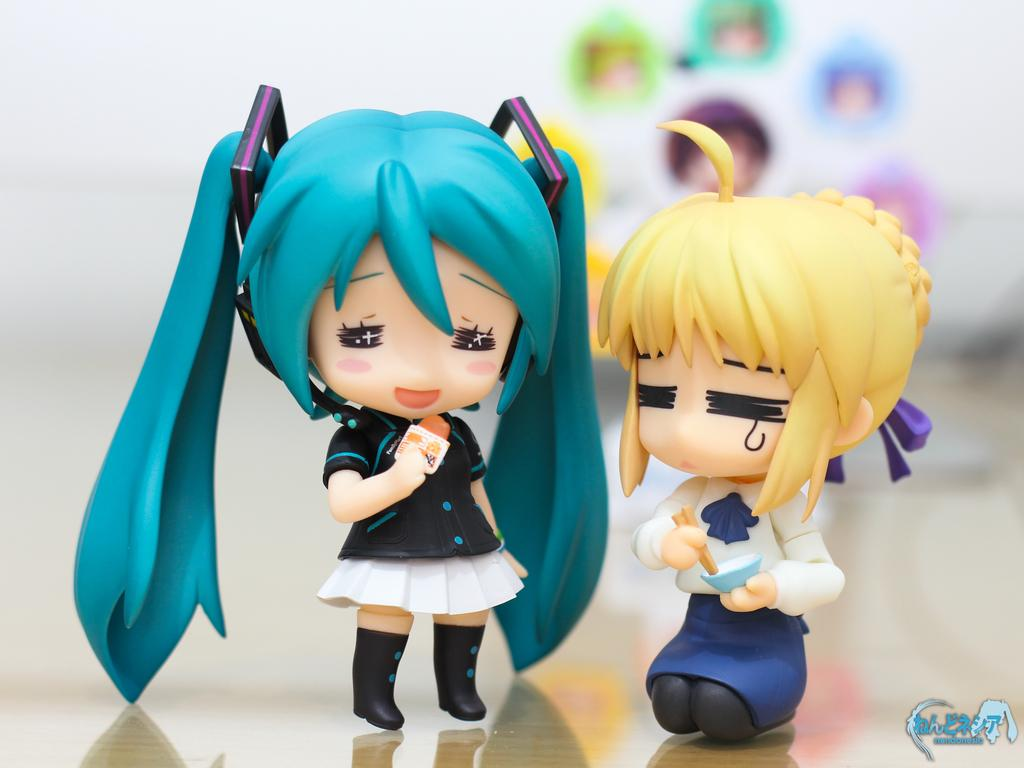What objects are present in the image? There are two toys in the image. Where are the toys located in the image? The toys are in the middle of the image. How many rabbits can be seen playing in the sand in the image? There are no rabbits or sand present in the image; it features two toys. Is there a judge presiding over a trial in the image? There is no judge or trial depicted in the image; it features two toys. 